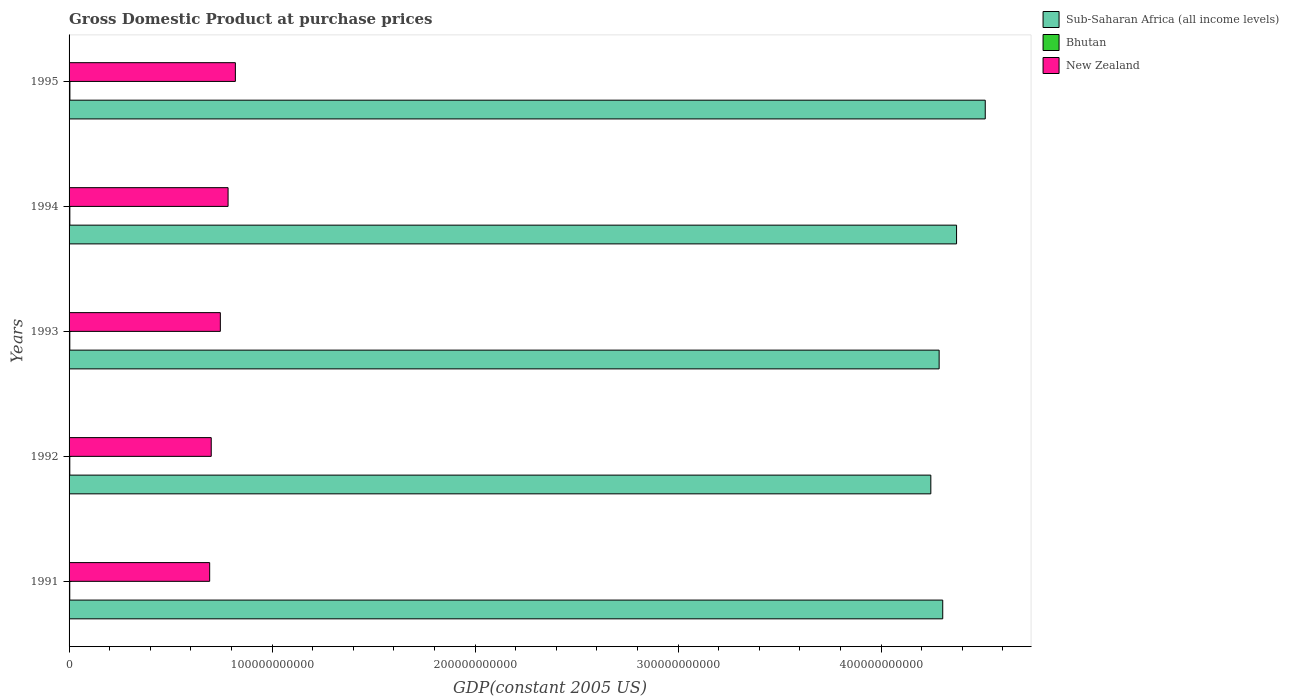How many groups of bars are there?
Make the answer very short. 5. Are the number of bars per tick equal to the number of legend labels?
Your response must be concise. Yes. In how many cases, is the number of bars for a given year not equal to the number of legend labels?
Keep it short and to the point. 0. What is the GDP at purchase prices in Bhutan in 1995?
Offer a very short reply. 4.11e+08. Across all years, what is the maximum GDP at purchase prices in Sub-Saharan Africa (all income levels)?
Ensure brevity in your answer.  4.51e+11. Across all years, what is the minimum GDP at purchase prices in New Zealand?
Your answer should be very brief. 6.93e+1. What is the total GDP at purchase prices in Sub-Saharan Africa (all income levels) in the graph?
Give a very brief answer. 2.17e+12. What is the difference between the GDP at purchase prices in Sub-Saharan Africa (all income levels) in 1992 and that in 1995?
Keep it short and to the point. -2.68e+1. What is the difference between the GDP at purchase prices in New Zealand in 1992 and the GDP at purchase prices in Bhutan in 1991?
Your answer should be compact. 6.97e+1. What is the average GDP at purchase prices in Bhutan per year?
Keep it short and to the point. 3.73e+08. In the year 1991, what is the difference between the GDP at purchase prices in Bhutan and GDP at purchase prices in New Zealand?
Keep it short and to the point. -6.89e+1. In how many years, is the GDP at purchase prices in New Zealand greater than 320000000000 US$?
Your answer should be compact. 0. What is the ratio of the GDP at purchase prices in Sub-Saharan Africa (all income levels) in 1992 to that in 1995?
Give a very brief answer. 0.94. Is the GDP at purchase prices in Bhutan in 1992 less than that in 1994?
Keep it short and to the point. Yes. Is the difference between the GDP at purchase prices in Bhutan in 1991 and 1993 greater than the difference between the GDP at purchase prices in New Zealand in 1991 and 1993?
Give a very brief answer. Yes. What is the difference between the highest and the second highest GDP at purchase prices in Sub-Saharan Africa (all income levels)?
Offer a terse response. 1.41e+1. What is the difference between the highest and the lowest GDP at purchase prices in New Zealand?
Provide a succinct answer. 1.27e+1. Is the sum of the GDP at purchase prices in New Zealand in 1993 and 1994 greater than the maximum GDP at purchase prices in Bhutan across all years?
Keep it short and to the point. Yes. What does the 2nd bar from the top in 1993 represents?
Your answer should be very brief. Bhutan. What does the 1st bar from the bottom in 1991 represents?
Your answer should be very brief. Sub-Saharan Africa (all income levels). How many bars are there?
Your response must be concise. 15. Are all the bars in the graph horizontal?
Offer a very short reply. Yes. How many years are there in the graph?
Your answer should be very brief. 5. What is the difference between two consecutive major ticks on the X-axis?
Offer a terse response. 1.00e+11. Are the values on the major ticks of X-axis written in scientific E-notation?
Provide a succinct answer. No. Does the graph contain any zero values?
Provide a short and direct response. No. Does the graph contain grids?
Provide a succinct answer. No. How many legend labels are there?
Give a very brief answer. 3. What is the title of the graph?
Keep it short and to the point. Gross Domestic Product at purchase prices. What is the label or title of the X-axis?
Your answer should be very brief. GDP(constant 2005 US). What is the GDP(constant 2005 US) in Sub-Saharan Africa (all income levels) in 1991?
Give a very brief answer. 4.30e+11. What is the GDP(constant 2005 US) in Bhutan in 1991?
Offer a terse response. 3.43e+08. What is the GDP(constant 2005 US) of New Zealand in 1991?
Give a very brief answer. 6.93e+1. What is the GDP(constant 2005 US) of Sub-Saharan Africa (all income levels) in 1992?
Keep it short and to the point. 4.24e+11. What is the GDP(constant 2005 US) in Bhutan in 1992?
Give a very brief answer. 3.59e+08. What is the GDP(constant 2005 US) in New Zealand in 1992?
Ensure brevity in your answer.  7.00e+1. What is the GDP(constant 2005 US) of Sub-Saharan Africa (all income levels) in 1993?
Make the answer very short. 4.29e+11. What is the GDP(constant 2005 US) of Bhutan in 1993?
Offer a very short reply. 3.66e+08. What is the GDP(constant 2005 US) of New Zealand in 1993?
Give a very brief answer. 7.45e+1. What is the GDP(constant 2005 US) in Sub-Saharan Africa (all income levels) in 1994?
Provide a short and direct response. 4.37e+11. What is the GDP(constant 2005 US) of Bhutan in 1994?
Provide a short and direct response. 3.84e+08. What is the GDP(constant 2005 US) of New Zealand in 1994?
Provide a short and direct response. 7.83e+1. What is the GDP(constant 2005 US) of Sub-Saharan Africa (all income levels) in 1995?
Your answer should be very brief. 4.51e+11. What is the GDP(constant 2005 US) of Bhutan in 1995?
Offer a very short reply. 4.11e+08. What is the GDP(constant 2005 US) of New Zealand in 1995?
Your response must be concise. 8.19e+1. Across all years, what is the maximum GDP(constant 2005 US) of Sub-Saharan Africa (all income levels)?
Give a very brief answer. 4.51e+11. Across all years, what is the maximum GDP(constant 2005 US) in Bhutan?
Offer a terse response. 4.11e+08. Across all years, what is the maximum GDP(constant 2005 US) of New Zealand?
Offer a terse response. 8.19e+1. Across all years, what is the minimum GDP(constant 2005 US) in Sub-Saharan Africa (all income levels)?
Give a very brief answer. 4.24e+11. Across all years, what is the minimum GDP(constant 2005 US) in Bhutan?
Provide a succinct answer. 3.43e+08. Across all years, what is the minimum GDP(constant 2005 US) in New Zealand?
Your answer should be very brief. 6.93e+1. What is the total GDP(constant 2005 US) of Sub-Saharan Africa (all income levels) in the graph?
Offer a very short reply. 2.17e+12. What is the total GDP(constant 2005 US) in Bhutan in the graph?
Provide a short and direct response. 1.86e+09. What is the total GDP(constant 2005 US) of New Zealand in the graph?
Give a very brief answer. 3.74e+11. What is the difference between the GDP(constant 2005 US) of Sub-Saharan Africa (all income levels) in 1991 and that in 1992?
Give a very brief answer. 5.86e+09. What is the difference between the GDP(constant 2005 US) in Bhutan in 1991 and that in 1992?
Your answer should be very brief. -1.58e+07. What is the difference between the GDP(constant 2005 US) of New Zealand in 1991 and that in 1992?
Give a very brief answer. -7.71e+08. What is the difference between the GDP(constant 2005 US) of Sub-Saharan Africa (all income levels) in 1991 and that in 1993?
Make the answer very short. 1.77e+09. What is the difference between the GDP(constant 2005 US) of Bhutan in 1991 and that in 1993?
Provide a succinct answer. -2.29e+07. What is the difference between the GDP(constant 2005 US) of New Zealand in 1991 and that in 1993?
Provide a succinct answer. -5.26e+09. What is the difference between the GDP(constant 2005 US) of Sub-Saharan Africa (all income levels) in 1991 and that in 1994?
Offer a very short reply. -6.82e+09. What is the difference between the GDP(constant 2005 US) of Bhutan in 1991 and that in 1994?
Keep it short and to the point. -4.10e+07. What is the difference between the GDP(constant 2005 US) in New Zealand in 1991 and that in 1994?
Provide a short and direct response. -9.07e+09. What is the difference between the GDP(constant 2005 US) in Sub-Saharan Africa (all income levels) in 1991 and that in 1995?
Give a very brief answer. -2.09e+1. What is the difference between the GDP(constant 2005 US) of Bhutan in 1991 and that in 1995?
Offer a terse response. -6.82e+07. What is the difference between the GDP(constant 2005 US) of New Zealand in 1991 and that in 1995?
Keep it short and to the point. -1.27e+1. What is the difference between the GDP(constant 2005 US) of Sub-Saharan Africa (all income levels) in 1992 and that in 1993?
Provide a short and direct response. -4.09e+09. What is the difference between the GDP(constant 2005 US) in Bhutan in 1992 and that in 1993?
Make the answer very short. -7.13e+06. What is the difference between the GDP(constant 2005 US) in New Zealand in 1992 and that in 1993?
Your response must be concise. -4.49e+09. What is the difference between the GDP(constant 2005 US) of Sub-Saharan Africa (all income levels) in 1992 and that in 1994?
Offer a very short reply. -1.27e+1. What is the difference between the GDP(constant 2005 US) in Bhutan in 1992 and that in 1994?
Give a very brief answer. -2.53e+07. What is the difference between the GDP(constant 2005 US) of New Zealand in 1992 and that in 1994?
Ensure brevity in your answer.  -8.29e+09. What is the difference between the GDP(constant 2005 US) in Sub-Saharan Africa (all income levels) in 1992 and that in 1995?
Keep it short and to the point. -2.68e+1. What is the difference between the GDP(constant 2005 US) of Bhutan in 1992 and that in 1995?
Ensure brevity in your answer.  -5.24e+07. What is the difference between the GDP(constant 2005 US) in New Zealand in 1992 and that in 1995?
Offer a very short reply. -1.19e+1. What is the difference between the GDP(constant 2005 US) of Sub-Saharan Africa (all income levels) in 1993 and that in 1994?
Give a very brief answer. -8.59e+09. What is the difference between the GDP(constant 2005 US) of Bhutan in 1993 and that in 1994?
Your response must be concise. -1.81e+07. What is the difference between the GDP(constant 2005 US) in New Zealand in 1993 and that in 1994?
Your answer should be compact. -3.80e+09. What is the difference between the GDP(constant 2005 US) in Sub-Saharan Africa (all income levels) in 1993 and that in 1995?
Your response must be concise. -2.27e+1. What is the difference between the GDP(constant 2005 US) of Bhutan in 1993 and that in 1995?
Your answer should be compact. -4.53e+07. What is the difference between the GDP(constant 2005 US) of New Zealand in 1993 and that in 1995?
Provide a short and direct response. -7.40e+09. What is the difference between the GDP(constant 2005 US) of Sub-Saharan Africa (all income levels) in 1994 and that in 1995?
Provide a succinct answer. -1.41e+1. What is the difference between the GDP(constant 2005 US) in Bhutan in 1994 and that in 1995?
Offer a very short reply. -2.72e+07. What is the difference between the GDP(constant 2005 US) of New Zealand in 1994 and that in 1995?
Make the answer very short. -3.60e+09. What is the difference between the GDP(constant 2005 US) of Sub-Saharan Africa (all income levels) in 1991 and the GDP(constant 2005 US) of Bhutan in 1992?
Ensure brevity in your answer.  4.30e+11. What is the difference between the GDP(constant 2005 US) in Sub-Saharan Africa (all income levels) in 1991 and the GDP(constant 2005 US) in New Zealand in 1992?
Provide a short and direct response. 3.60e+11. What is the difference between the GDP(constant 2005 US) in Bhutan in 1991 and the GDP(constant 2005 US) in New Zealand in 1992?
Provide a short and direct response. -6.97e+1. What is the difference between the GDP(constant 2005 US) in Sub-Saharan Africa (all income levels) in 1991 and the GDP(constant 2005 US) in Bhutan in 1993?
Your answer should be compact. 4.30e+11. What is the difference between the GDP(constant 2005 US) in Sub-Saharan Africa (all income levels) in 1991 and the GDP(constant 2005 US) in New Zealand in 1993?
Give a very brief answer. 3.56e+11. What is the difference between the GDP(constant 2005 US) of Bhutan in 1991 and the GDP(constant 2005 US) of New Zealand in 1993?
Your answer should be very brief. -7.42e+1. What is the difference between the GDP(constant 2005 US) of Sub-Saharan Africa (all income levels) in 1991 and the GDP(constant 2005 US) of Bhutan in 1994?
Your answer should be very brief. 4.30e+11. What is the difference between the GDP(constant 2005 US) of Sub-Saharan Africa (all income levels) in 1991 and the GDP(constant 2005 US) of New Zealand in 1994?
Offer a very short reply. 3.52e+11. What is the difference between the GDP(constant 2005 US) of Bhutan in 1991 and the GDP(constant 2005 US) of New Zealand in 1994?
Your answer should be compact. -7.80e+1. What is the difference between the GDP(constant 2005 US) in Sub-Saharan Africa (all income levels) in 1991 and the GDP(constant 2005 US) in Bhutan in 1995?
Keep it short and to the point. 4.30e+11. What is the difference between the GDP(constant 2005 US) of Sub-Saharan Africa (all income levels) in 1991 and the GDP(constant 2005 US) of New Zealand in 1995?
Give a very brief answer. 3.48e+11. What is the difference between the GDP(constant 2005 US) in Bhutan in 1991 and the GDP(constant 2005 US) in New Zealand in 1995?
Provide a succinct answer. -8.16e+1. What is the difference between the GDP(constant 2005 US) in Sub-Saharan Africa (all income levels) in 1992 and the GDP(constant 2005 US) in Bhutan in 1993?
Provide a short and direct response. 4.24e+11. What is the difference between the GDP(constant 2005 US) of Sub-Saharan Africa (all income levels) in 1992 and the GDP(constant 2005 US) of New Zealand in 1993?
Give a very brief answer. 3.50e+11. What is the difference between the GDP(constant 2005 US) in Bhutan in 1992 and the GDP(constant 2005 US) in New Zealand in 1993?
Your answer should be very brief. -7.42e+1. What is the difference between the GDP(constant 2005 US) in Sub-Saharan Africa (all income levels) in 1992 and the GDP(constant 2005 US) in Bhutan in 1994?
Offer a terse response. 4.24e+11. What is the difference between the GDP(constant 2005 US) of Sub-Saharan Africa (all income levels) in 1992 and the GDP(constant 2005 US) of New Zealand in 1994?
Ensure brevity in your answer.  3.46e+11. What is the difference between the GDP(constant 2005 US) in Bhutan in 1992 and the GDP(constant 2005 US) in New Zealand in 1994?
Provide a succinct answer. -7.80e+1. What is the difference between the GDP(constant 2005 US) in Sub-Saharan Africa (all income levels) in 1992 and the GDP(constant 2005 US) in Bhutan in 1995?
Make the answer very short. 4.24e+11. What is the difference between the GDP(constant 2005 US) of Sub-Saharan Africa (all income levels) in 1992 and the GDP(constant 2005 US) of New Zealand in 1995?
Ensure brevity in your answer.  3.43e+11. What is the difference between the GDP(constant 2005 US) in Bhutan in 1992 and the GDP(constant 2005 US) in New Zealand in 1995?
Your answer should be very brief. -8.16e+1. What is the difference between the GDP(constant 2005 US) of Sub-Saharan Africa (all income levels) in 1993 and the GDP(constant 2005 US) of Bhutan in 1994?
Provide a succinct answer. 4.28e+11. What is the difference between the GDP(constant 2005 US) of Sub-Saharan Africa (all income levels) in 1993 and the GDP(constant 2005 US) of New Zealand in 1994?
Ensure brevity in your answer.  3.50e+11. What is the difference between the GDP(constant 2005 US) of Bhutan in 1993 and the GDP(constant 2005 US) of New Zealand in 1994?
Provide a short and direct response. -7.80e+1. What is the difference between the GDP(constant 2005 US) of Sub-Saharan Africa (all income levels) in 1993 and the GDP(constant 2005 US) of Bhutan in 1995?
Offer a terse response. 4.28e+11. What is the difference between the GDP(constant 2005 US) in Sub-Saharan Africa (all income levels) in 1993 and the GDP(constant 2005 US) in New Zealand in 1995?
Keep it short and to the point. 3.47e+11. What is the difference between the GDP(constant 2005 US) in Bhutan in 1993 and the GDP(constant 2005 US) in New Zealand in 1995?
Make the answer very short. -8.15e+1. What is the difference between the GDP(constant 2005 US) of Sub-Saharan Africa (all income levels) in 1994 and the GDP(constant 2005 US) of Bhutan in 1995?
Provide a short and direct response. 4.37e+11. What is the difference between the GDP(constant 2005 US) of Sub-Saharan Africa (all income levels) in 1994 and the GDP(constant 2005 US) of New Zealand in 1995?
Provide a succinct answer. 3.55e+11. What is the difference between the GDP(constant 2005 US) in Bhutan in 1994 and the GDP(constant 2005 US) in New Zealand in 1995?
Provide a short and direct response. -8.15e+1. What is the average GDP(constant 2005 US) in Sub-Saharan Africa (all income levels) per year?
Keep it short and to the point. 4.34e+11. What is the average GDP(constant 2005 US) in Bhutan per year?
Keep it short and to the point. 3.73e+08. What is the average GDP(constant 2005 US) in New Zealand per year?
Offer a very short reply. 7.48e+1. In the year 1991, what is the difference between the GDP(constant 2005 US) of Sub-Saharan Africa (all income levels) and GDP(constant 2005 US) of Bhutan?
Provide a succinct answer. 4.30e+11. In the year 1991, what is the difference between the GDP(constant 2005 US) in Sub-Saharan Africa (all income levels) and GDP(constant 2005 US) in New Zealand?
Ensure brevity in your answer.  3.61e+11. In the year 1991, what is the difference between the GDP(constant 2005 US) in Bhutan and GDP(constant 2005 US) in New Zealand?
Keep it short and to the point. -6.89e+1. In the year 1992, what is the difference between the GDP(constant 2005 US) of Sub-Saharan Africa (all income levels) and GDP(constant 2005 US) of Bhutan?
Keep it short and to the point. 4.24e+11. In the year 1992, what is the difference between the GDP(constant 2005 US) of Sub-Saharan Africa (all income levels) and GDP(constant 2005 US) of New Zealand?
Offer a very short reply. 3.54e+11. In the year 1992, what is the difference between the GDP(constant 2005 US) in Bhutan and GDP(constant 2005 US) in New Zealand?
Ensure brevity in your answer.  -6.97e+1. In the year 1993, what is the difference between the GDP(constant 2005 US) of Sub-Saharan Africa (all income levels) and GDP(constant 2005 US) of Bhutan?
Your answer should be very brief. 4.28e+11. In the year 1993, what is the difference between the GDP(constant 2005 US) in Sub-Saharan Africa (all income levels) and GDP(constant 2005 US) in New Zealand?
Your answer should be compact. 3.54e+11. In the year 1993, what is the difference between the GDP(constant 2005 US) in Bhutan and GDP(constant 2005 US) in New Zealand?
Make the answer very short. -7.41e+1. In the year 1994, what is the difference between the GDP(constant 2005 US) in Sub-Saharan Africa (all income levels) and GDP(constant 2005 US) in Bhutan?
Ensure brevity in your answer.  4.37e+11. In the year 1994, what is the difference between the GDP(constant 2005 US) of Sub-Saharan Africa (all income levels) and GDP(constant 2005 US) of New Zealand?
Provide a succinct answer. 3.59e+11. In the year 1994, what is the difference between the GDP(constant 2005 US) in Bhutan and GDP(constant 2005 US) in New Zealand?
Your answer should be compact. -7.79e+1. In the year 1995, what is the difference between the GDP(constant 2005 US) of Sub-Saharan Africa (all income levels) and GDP(constant 2005 US) of Bhutan?
Give a very brief answer. 4.51e+11. In the year 1995, what is the difference between the GDP(constant 2005 US) of Sub-Saharan Africa (all income levels) and GDP(constant 2005 US) of New Zealand?
Offer a very short reply. 3.69e+11. In the year 1995, what is the difference between the GDP(constant 2005 US) in Bhutan and GDP(constant 2005 US) in New Zealand?
Provide a short and direct response. -8.15e+1. What is the ratio of the GDP(constant 2005 US) of Sub-Saharan Africa (all income levels) in 1991 to that in 1992?
Your answer should be very brief. 1.01. What is the ratio of the GDP(constant 2005 US) in Bhutan in 1991 to that in 1992?
Your response must be concise. 0.96. What is the ratio of the GDP(constant 2005 US) of Bhutan in 1991 to that in 1993?
Your answer should be very brief. 0.94. What is the ratio of the GDP(constant 2005 US) of New Zealand in 1991 to that in 1993?
Give a very brief answer. 0.93. What is the ratio of the GDP(constant 2005 US) in Sub-Saharan Africa (all income levels) in 1991 to that in 1994?
Provide a short and direct response. 0.98. What is the ratio of the GDP(constant 2005 US) in Bhutan in 1991 to that in 1994?
Make the answer very short. 0.89. What is the ratio of the GDP(constant 2005 US) in New Zealand in 1991 to that in 1994?
Your answer should be very brief. 0.88. What is the ratio of the GDP(constant 2005 US) in Sub-Saharan Africa (all income levels) in 1991 to that in 1995?
Give a very brief answer. 0.95. What is the ratio of the GDP(constant 2005 US) in Bhutan in 1991 to that in 1995?
Provide a succinct answer. 0.83. What is the ratio of the GDP(constant 2005 US) in New Zealand in 1991 to that in 1995?
Give a very brief answer. 0.85. What is the ratio of the GDP(constant 2005 US) of Bhutan in 1992 to that in 1993?
Provide a short and direct response. 0.98. What is the ratio of the GDP(constant 2005 US) of New Zealand in 1992 to that in 1993?
Offer a very short reply. 0.94. What is the ratio of the GDP(constant 2005 US) in Sub-Saharan Africa (all income levels) in 1992 to that in 1994?
Provide a short and direct response. 0.97. What is the ratio of the GDP(constant 2005 US) in Bhutan in 1992 to that in 1994?
Offer a terse response. 0.93. What is the ratio of the GDP(constant 2005 US) of New Zealand in 1992 to that in 1994?
Provide a short and direct response. 0.89. What is the ratio of the GDP(constant 2005 US) of Sub-Saharan Africa (all income levels) in 1992 to that in 1995?
Keep it short and to the point. 0.94. What is the ratio of the GDP(constant 2005 US) in Bhutan in 1992 to that in 1995?
Your answer should be very brief. 0.87. What is the ratio of the GDP(constant 2005 US) of New Zealand in 1992 to that in 1995?
Your response must be concise. 0.85. What is the ratio of the GDP(constant 2005 US) in Sub-Saharan Africa (all income levels) in 1993 to that in 1994?
Provide a succinct answer. 0.98. What is the ratio of the GDP(constant 2005 US) of Bhutan in 1993 to that in 1994?
Your answer should be very brief. 0.95. What is the ratio of the GDP(constant 2005 US) of New Zealand in 1993 to that in 1994?
Make the answer very short. 0.95. What is the ratio of the GDP(constant 2005 US) of Sub-Saharan Africa (all income levels) in 1993 to that in 1995?
Offer a terse response. 0.95. What is the ratio of the GDP(constant 2005 US) in Bhutan in 1993 to that in 1995?
Ensure brevity in your answer.  0.89. What is the ratio of the GDP(constant 2005 US) in New Zealand in 1993 to that in 1995?
Ensure brevity in your answer.  0.91. What is the ratio of the GDP(constant 2005 US) in Sub-Saharan Africa (all income levels) in 1994 to that in 1995?
Offer a terse response. 0.97. What is the ratio of the GDP(constant 2005 US) in Bhutan in 1994 to that in 1995?
Offer a terse response. 0.93. What is the ratio of the GDP(constant 2005 US) in New Zealand in 1994 to that in 1995?
Make the answer very short. 0.96. What is the difference between the highest and the second highest GDP(constant 2005 US) of Sub-Saharan Africa (all income levels)?
Your response must be concise. 1.41e+1. What is the difference between the highest and the second highest GDP(constant 2005 US) in Bhutan?
Give a very brief answer. 2.72e+07. What is the difference between the highest and the second highest GDP(constant 2005 US) in New Zealand?
Your answer should be very brief. 3.60e+09. What is the difference between the highest and the lowest GDP(constant 2005 US) in Sub-Saharan Africa (all income levels)?
Your response must be concise. 2.68e+1. What is the difference between the highest and the lowest GDP(constant 2005 US) in Bhutan?
Offer a very short reply. 6.82e+07. What is the difference between the highest and the lowest GDP(constant 2005 US) of New Zealand?
Provide a short and direct response. 1.27e+1. 